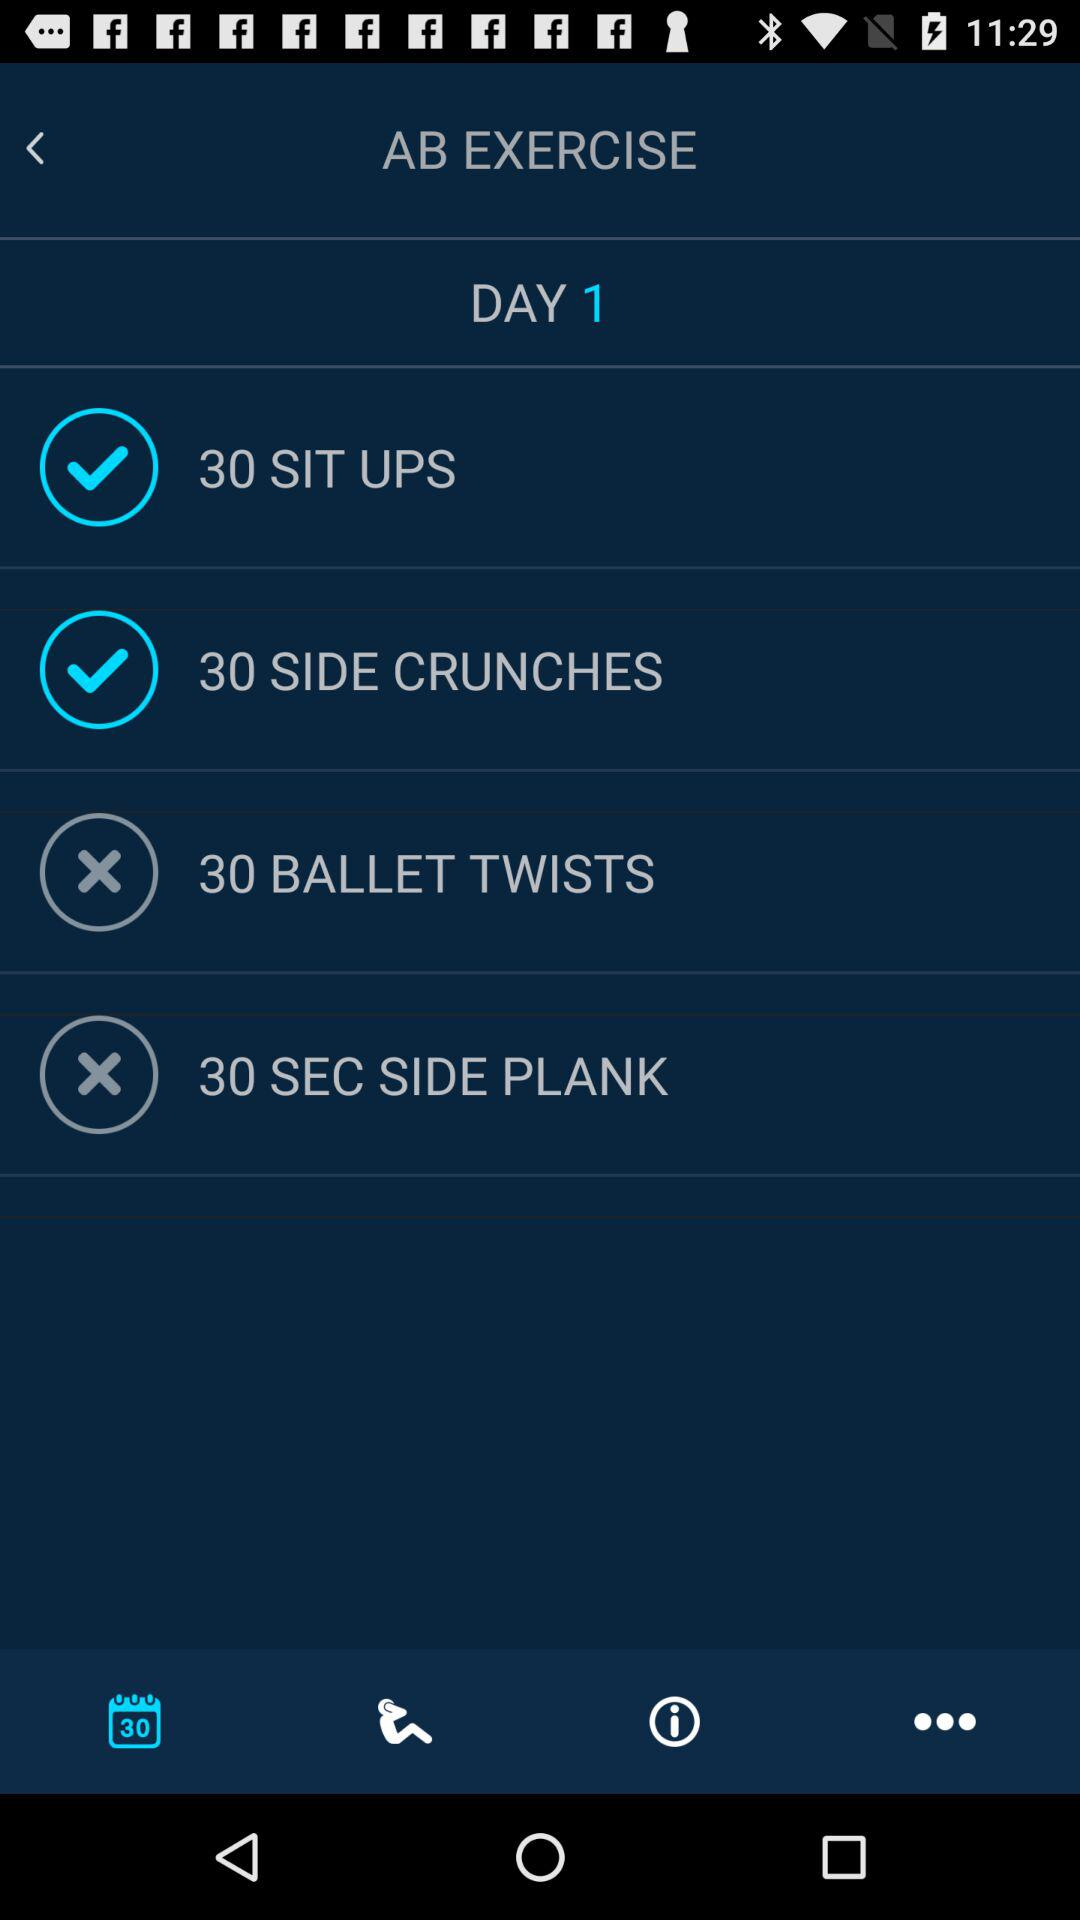Which exercises are completed? The completed exercises are 30 sit-ups and 30 side crunches. 